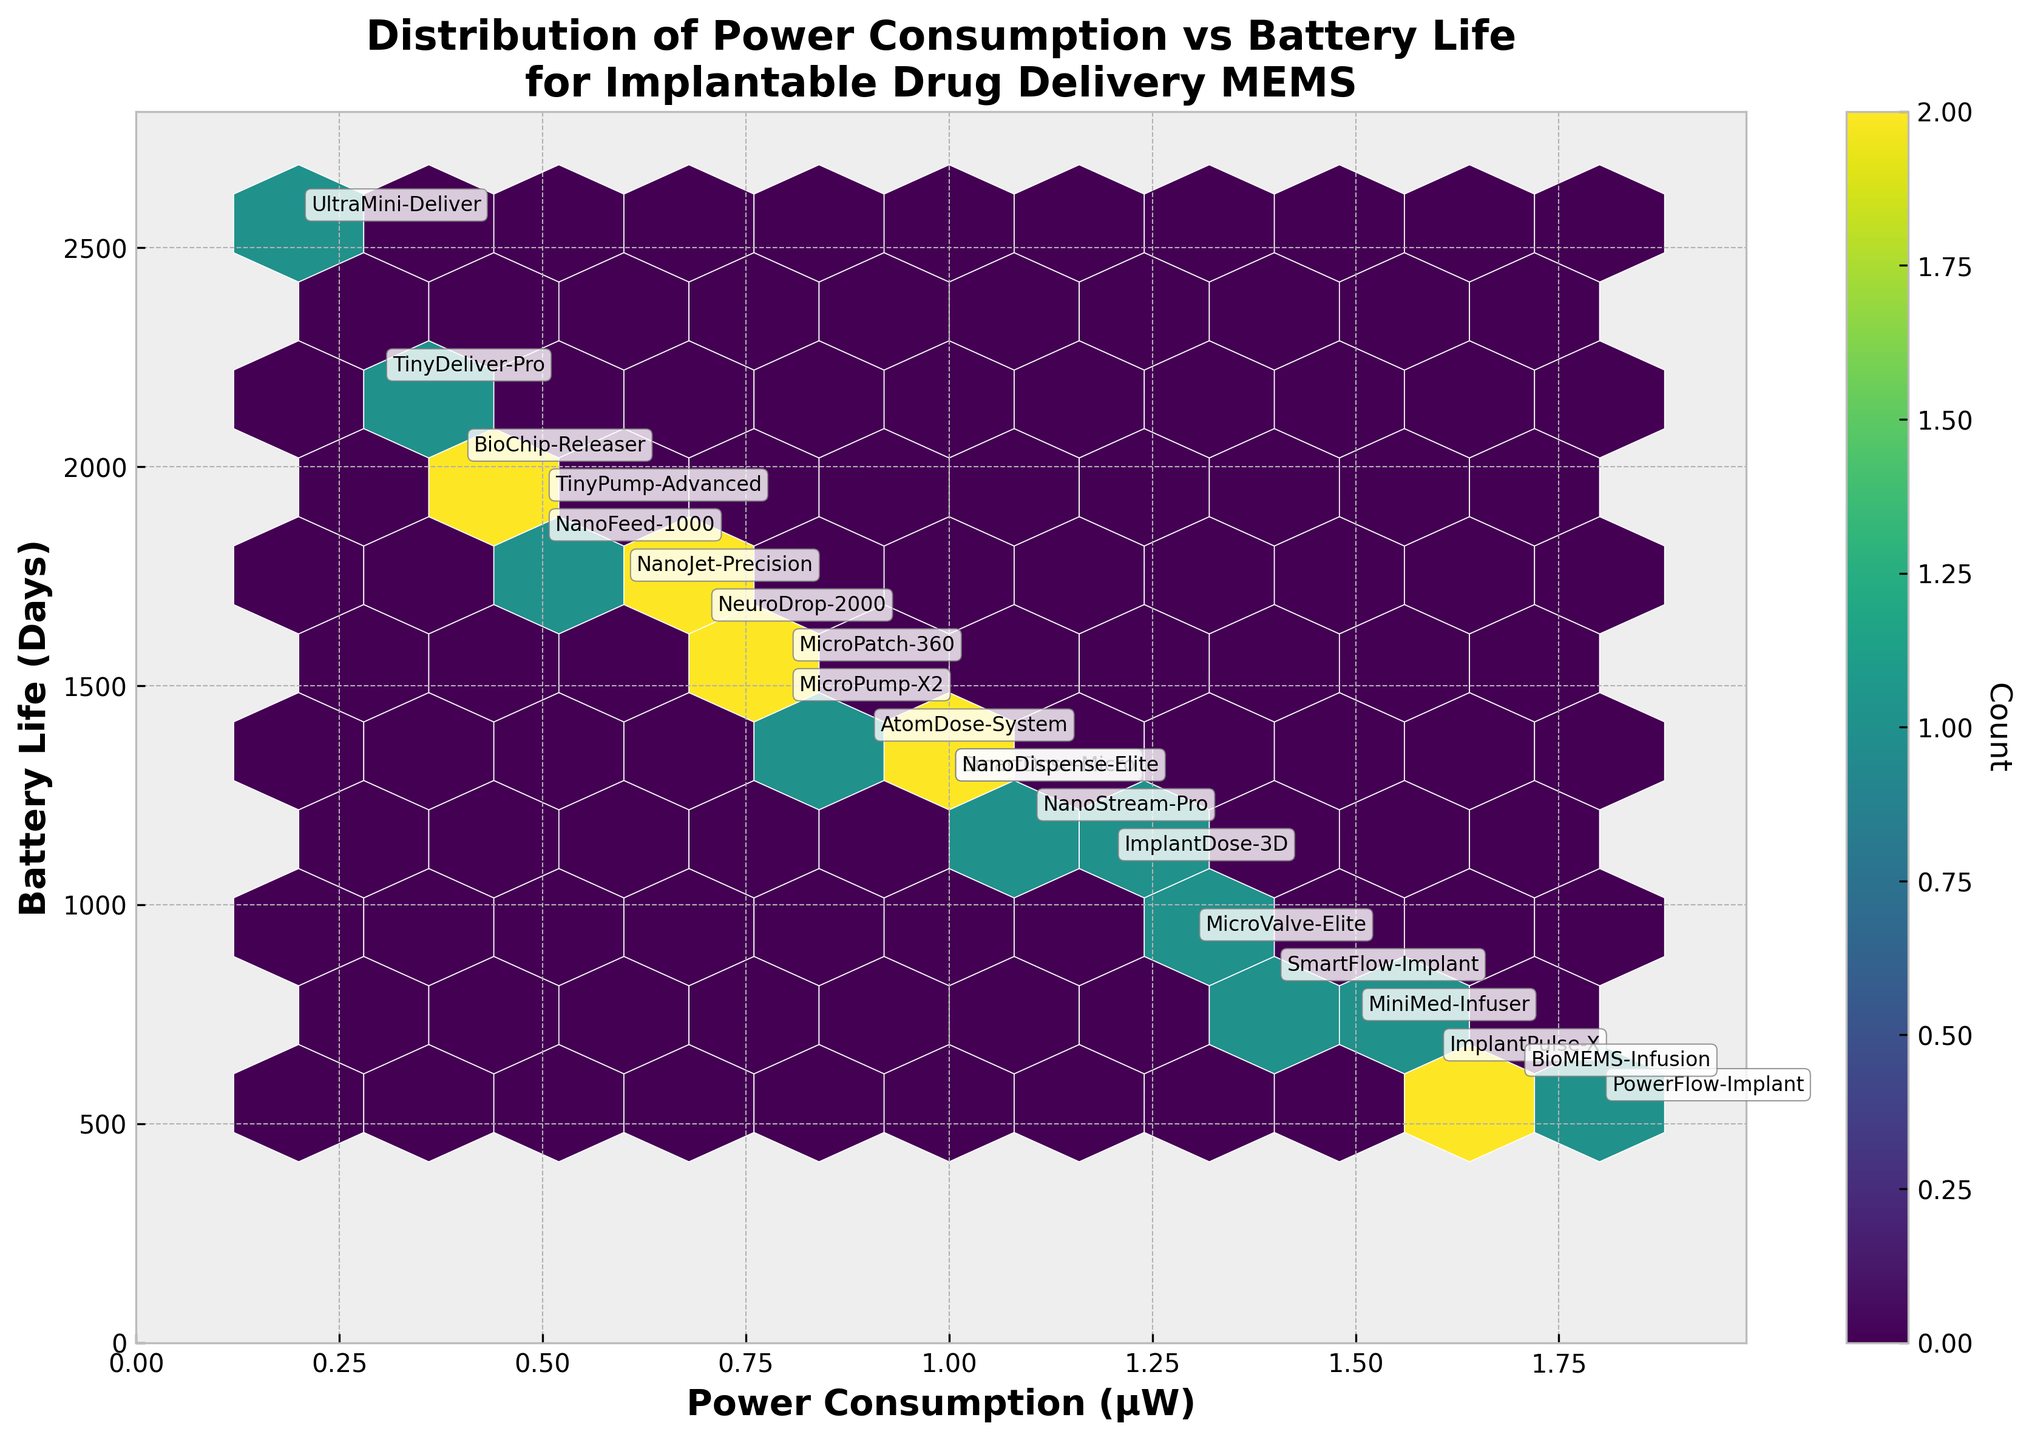What is the title of the plot? The title of the plot should be found at the top of the figure. It provides context for the data being represented. The title is "Distribution of Power Consumption vs Battery Life for Implantable Drug Delivery MEMS".
Answer: Distribution of Power Consumption vs Battery Life for Implantable Drug Delivery MEMS What do the axes represent? The x-axis represents 'Power Consumption (µW)' and the y-axis represents 'Battery Life (Days)'. This can be identified by reading the labels on both axes.
Answer: Power Consumption (µW) and Battery Life (Days) Which device has the highest power consumption and what is its battery life? By observing the hexbin plot and looking at the labeled points, the device with the highest power consumption is 'PowerFlow-Implant' with a power consumption of 1.8 µW. Its corresponding battery life is 547 days.
Answer: PowerFlow-Implant with a battery life of 547 days How many color shades are used to represent the count in the hexbin bins? The color bar on the right-hand side of the plot indicates the different colors used to represent the count of data points in each hexbin bin. By looking at the color bar, one can count the number of distinct color shades used.
Answer: Multiple shades (exact count varies depending on the plot) Which two devices have the closest power consumption values but different battery lives? To find this, one has to look at devices with nearly the same x-values (Power Consumption) but differing y-values (Battery Life). A close inspection reveals that 'MicroPatch-360' and 'MicroPump-X2' both have power consumption around 0.8 µW, but different battery lives of 1551 days and 1460 days respectively.
Answer: MicroPatch-360 and MicroPump-X2 What is the range of battery life values displayed on the plot? The range can be determined by looking at the y-axis and identifying the minimum and maximum battery life values among the labeled devices. The minimum battery life is 547 days ('PowerFlow-Implant') and the maximum is 2555 days ('UltraMini-Deliver').
Answer: 547 to 2555 days Which device has the longest battery life and what is its power consumption? By identifying the point located at the highest y-value on the plot, it is evident that 'UltraMini-Deliver' has the longest battery life of 2555 days. Its corresponding power consumption is 0.2 µW.
Answer: UltraMini-Deliver with a power consumption of 0.2 µW Is there a trend visible between power consumption and battery life? Observing the general direction of data points, one can infer that as power consumption increases, battery life tends to decrease. This indicates an inverse relationship.
Answer: Inverse relationship How many data points are there with power consumption greater than 1.0 µW? By looking at the x-axis and identifying the data points (devices) with x-values greater than 1.0 µW, there are 9 such data points.
Answer: 9 How does the density of data points change across different hexbin bins? The hexbin plot uses color intensity to indicate the count of data points in each bin. Therefore, denser areas will have bins with darker colors. By examining the color bar and the plot, one can see the areas with higher density have darker shades, indicating more data points in those regions.
Answer: Higher density is indicated by darker shades 